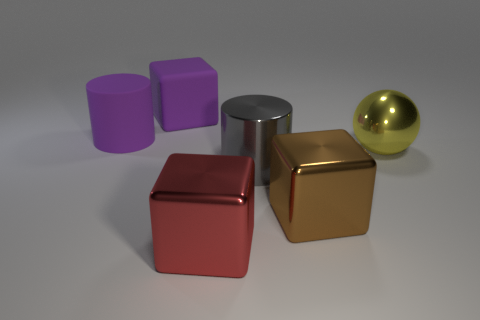How many rubber objects are small brown spheres or purple blocks?
Your answer should be very brief. 1. There is another cylinder that is the same size as the gray metal cylinder; what is its color?
Provide a succinct answer. Purple. How many large yellow things are the same shape as the red shiny object?
Offer a terse response. 0. What number of cubes are red things or brown metal objects?
Provide a short and direct response. 2. There is a large matte thing behind the big purple cylinder; is it the same shape as the metallic thing that is behind the big gray metallic thing?
Your answer should be compact. No. What is the red block made of?
Offer a very short reply. Metal. What shape is the big object that is the same color as the big matte cylinder?
Ensure brevity in your answer.  Cube. What number of gray metallic cylinders have the same size as the purple cylinder?
Provide a short and direct response. 1. How many things are cylinders that are in front of the large metal sphere or matte objects that are left of the big matte cube?
Provide a short and direct response. 2. Is the material of the purple object in front of the rubber block the same as the big block behind the large yellow sphere?
Your answer should be very brief. Yes. 